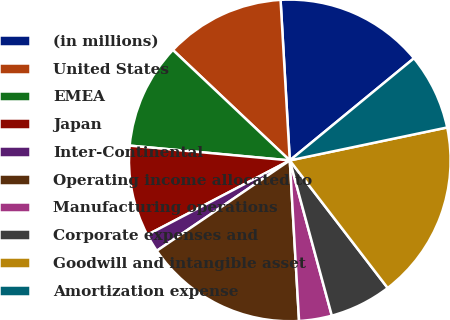Convert chart to OTSL. <chart><loc_0><loc_0><loc_500><loc_500><pie_chart><fcel>(in millions)<fcel>United States<fcel>EMEA<fcel>Japan<fcel>Inter-Continental<fcel>Operating income allocated to<fcel>Manufacturing operations<fcel>Corporate expenses and<fcel>Goodwill and intangible asset<fcel>Amortization expense<nl><fcel>14.96%<fcel>12.04%<fcel>10.58%<fcel>9.13%<fcel>1.84%<fcel>16.42%<fcel>3.29%<fcel>6.21%<fcel>17.87%<fcel>7.67%<nl></chart> 